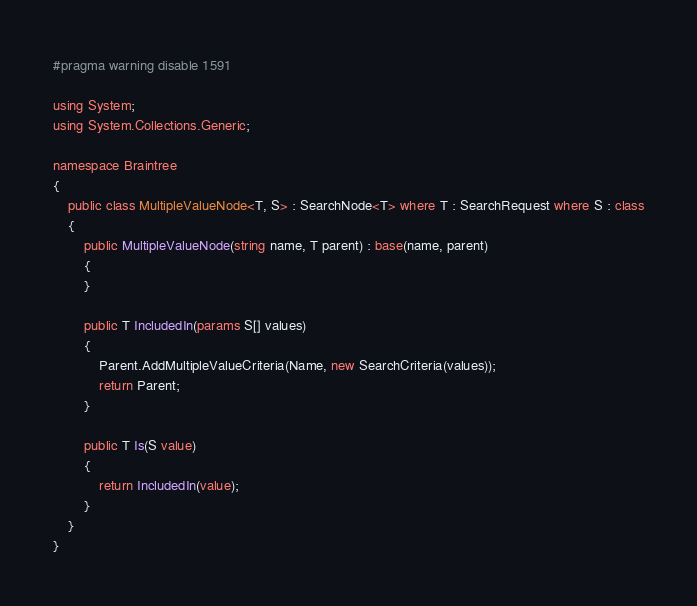<code> <loc_0><loc_0><loc_500><loc_500><_C#_>#pragma warning disable 1591

using System;
using System.Collections.Generic;

namespace Braintree
{
    public class MultipleValueNode<T, S> : SearchNode<T> where T : SearchRequest where S : class
    {
        public MultipleValueNode(string name, T parent) : base(name, parent)
        {
        }

        public T IncludedIn(params S[] values)
        {
            Parent.AddMultipleValueCriteria(Name, new SearchCriteria(values));
            return Parent;
        }

        public T Is(S value)
        {
            return IncludedIn(value);
        }
    }
}
</code> 